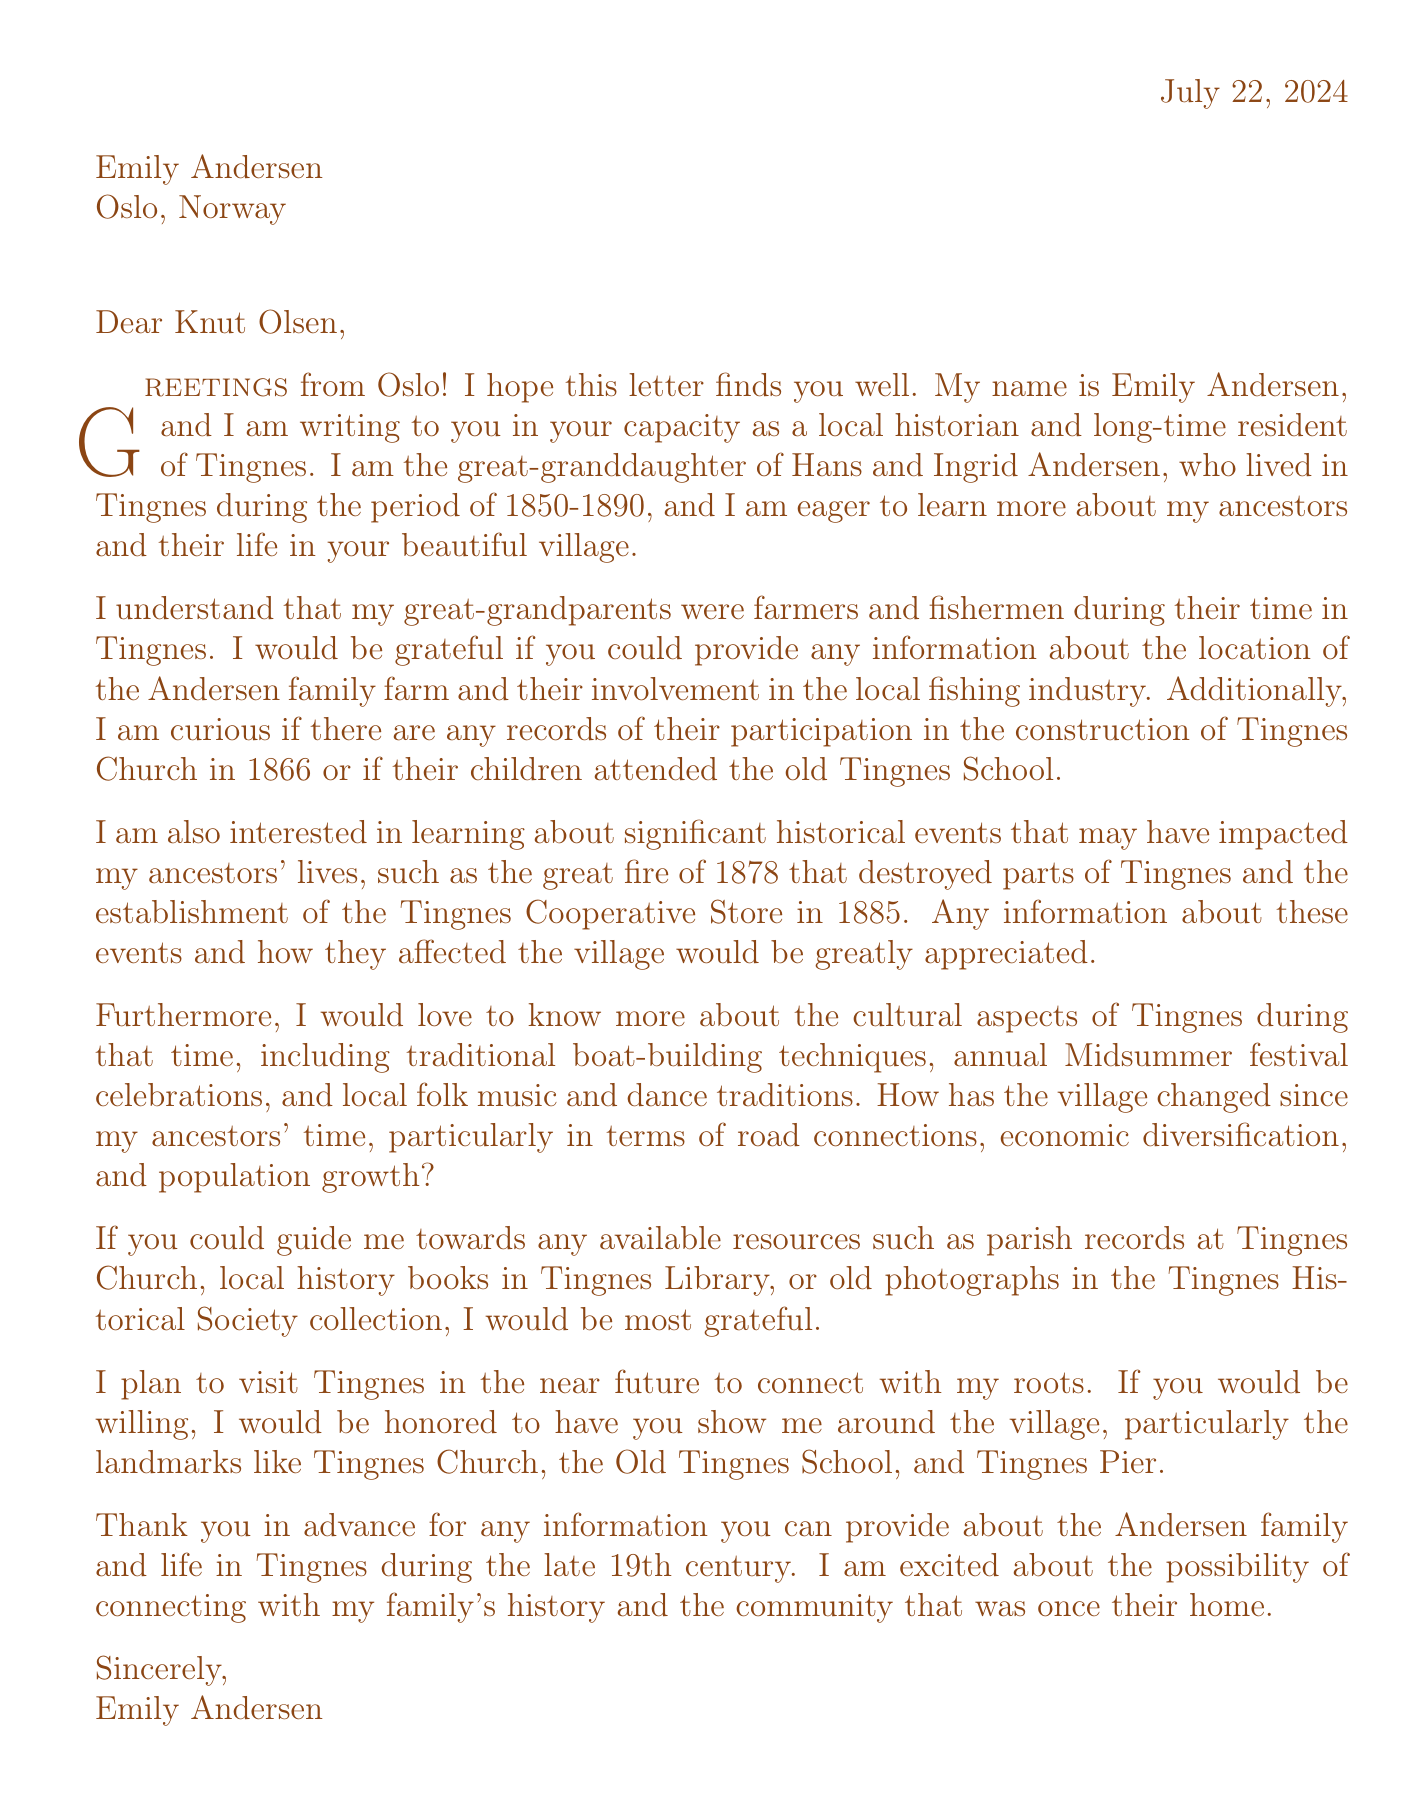What is the name of the sender? The sender's name is mentioned at the beginning of the letter as Emily Andersen.
Answer: Emily Andersen Who is the recipient of the letter? The recipient is named in the salutation of the letter.
Answer: Knut Olsen What time period is referenced for Hans and Ingrid Andersen? The specific time period during which Hans and Ingrid Andersen lived in Tingnes is stated in the letter.
Answer: 1850-1890 What occupation did Hans and Ingrid Andersen have? The letter mentions their occupations explicitly.
Answer: Farmers and fishermen What significant event is mentioned that occurred in 1878? The letter discusses a major historical event that affected the village.
Answer: The great fire Which local landmark is suggested for a visit? The document lists landmarks that are significant in Tingnes, with one mentioned explicitly for a visit.
Answer: Tingnes Church What resource is mentioned for parish records? The letter provides information on where to find records related to the church.
Answer: Tingnes Church What festival is referenced in the cultural aspects? The letter mentions a specific festival celebrated in Tingnes.
Answer: Midsummer festival What kind of event does Emily plan to do on her visit? The closing part of the letter mentions a planned activity during the visit.
Answer: Connect with her roots 